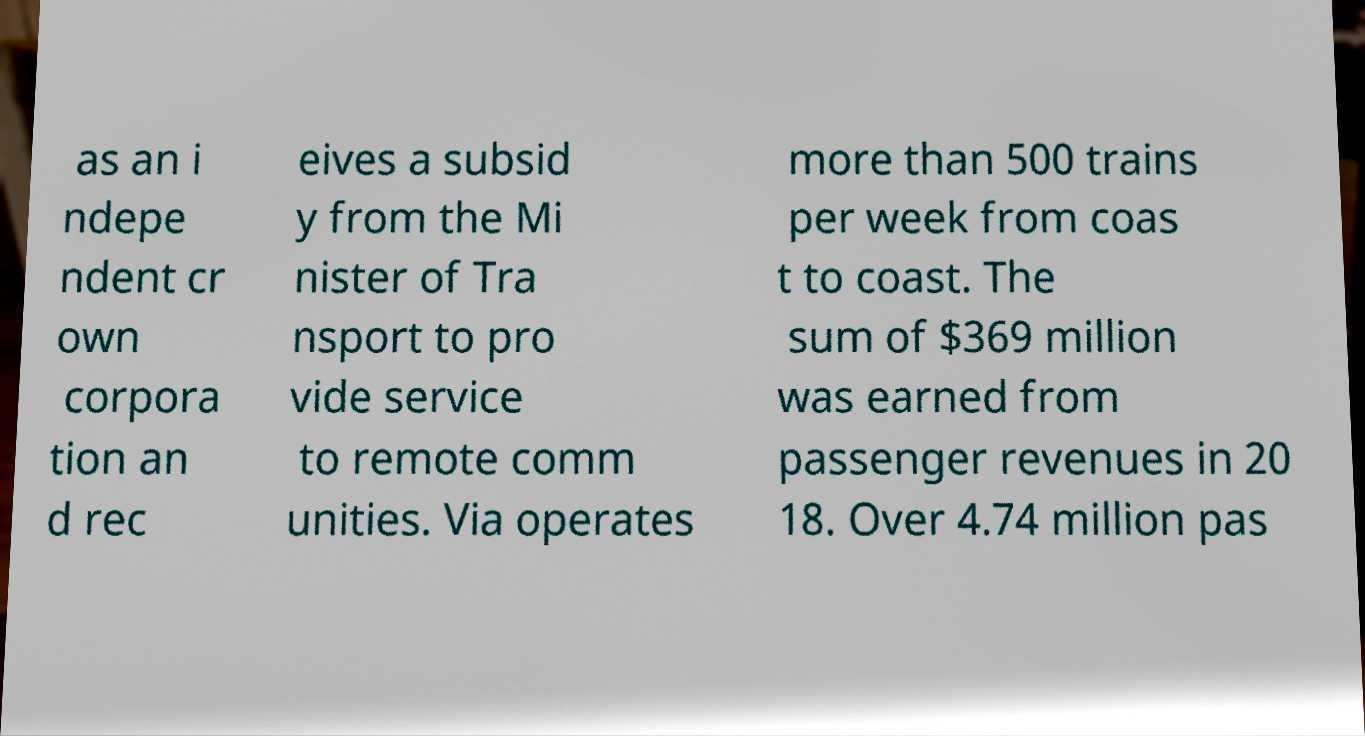Please read and relay the text visible in this image. What does it say? as an i ndepe ndent cr own corpora tion an d rec eives a subsid y from the Mi nister of Tra nsport to pro vide service to remote comm unities. Via operates more than 500 trains per week from coas t to coast. The sum of $369 million was earned from passenger revenues in 20 18. Over 4.74 million pas 